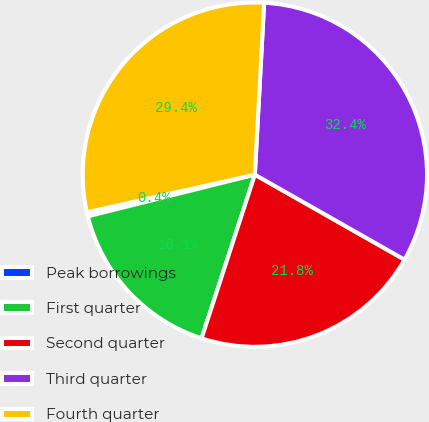Convert chart. <chart><loc_0><loc_0><loc_500><loc_500><pie_chart><fcel>Peak borrowings<fcel>First quarter<fcel>Second quarter<fcel>Third quarter<fcel>Fourth quarter<nl><fcel>0.38%<fcel>16.1%<fcel>21.79%<fcel>32.36%<fcel>29.37%<nl></chart> 